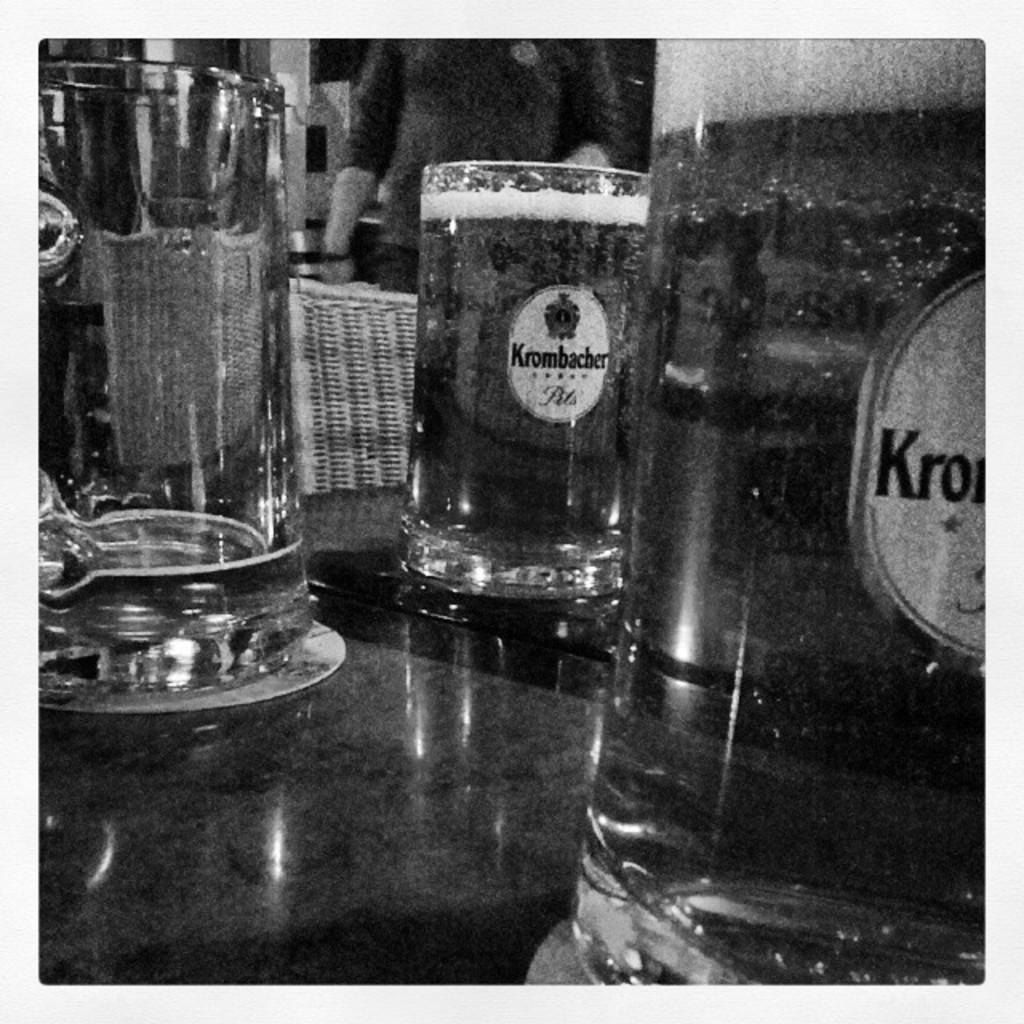What type of glasses can be seen on the table in the image? There are wine glasses and a water glass on the table in the image. What is on the table to protect it from spills or heat? There is a mat on the table in the image. What is the woman near in the image? The woman is standing near a wooden chair in the image. What is the woman wearing on her upper body? The woman is wearing a t-shirt in the image. What is the woman wearing on her lower body? The woman is wearing jeans in the image. What type of car is parked near the woman in the image? There is no car present in the image; it only features a woman, a wooden chair, and a table with glasses and a mat. What type of sign can be seen in the image? There is no sign present in the image. What type of skirt is the woman wearing in the image? The woman is not wearing a skirt in the image; she is wearing jeans. 